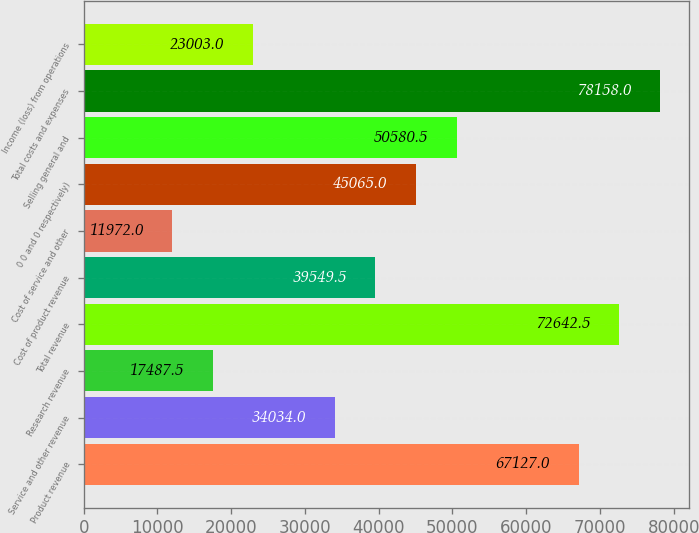Convert chart. <chart><loc_0><loc_0><loc_500><loc_500><bar_chart><fcel>Product revenue<fcel>Service and other revenue<fcel>Research revenue<fcel>Total revenue<fcel>Cost of product revenue<fcel>Cost of service and other<fcel>0 0 and 0 respectively)<fcel>Selling general and<fcel>Total costs and expenses<fcel>Income (loss) from operations<nl><fcel>67127<fcel>34034<fcel>17487.5<fcel>72642.5<fcel>39549.5<fcel>11972<fcel>45065<fcel>50580.5<fcel>78158<fcel>23003<nl></chart> 